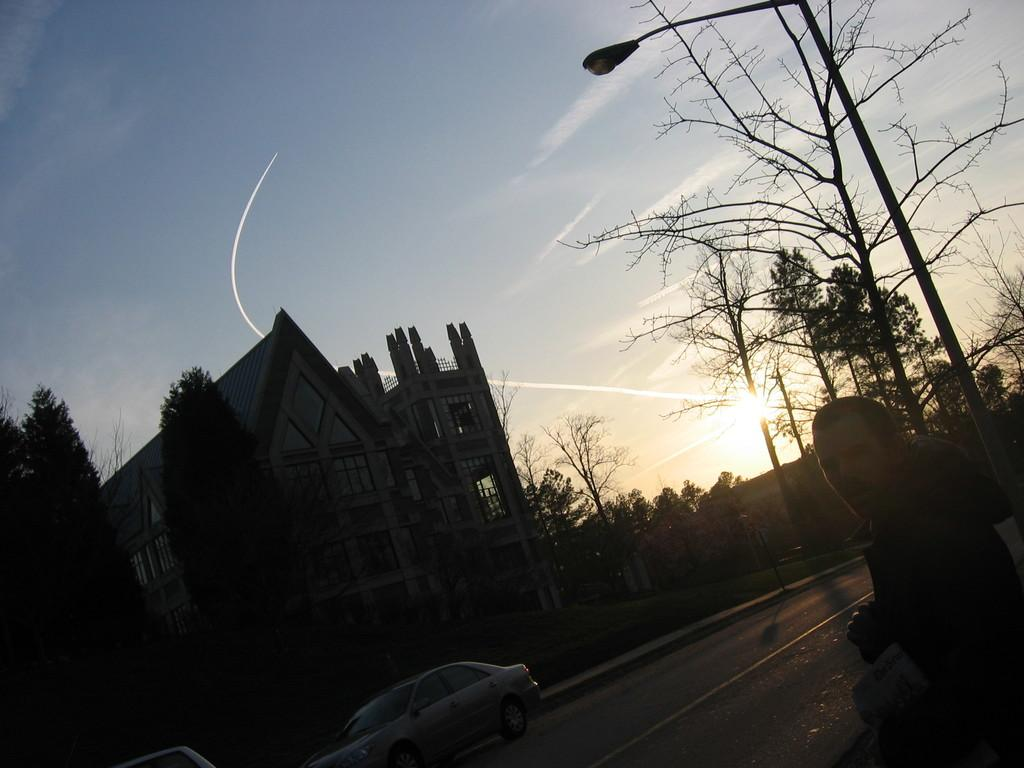What type of structure is present in the image? There is a building in the image. What else can be seen on the ground in the image? There are vehicles on the road in the image. What natural elements are present in the image? There are many trees in the image. What is visible in the background of the image? The sky is visible in the image. Who or what else is present in the image? There is a person in the image. What man-made object can be seen in the image? There is a light pole in the image. Can you see any deer grazing near the building in the image? There are no deer present in the image. What type of spade is being used by the person in the image? There is no spade visible in the image, nor is there a person using one. 